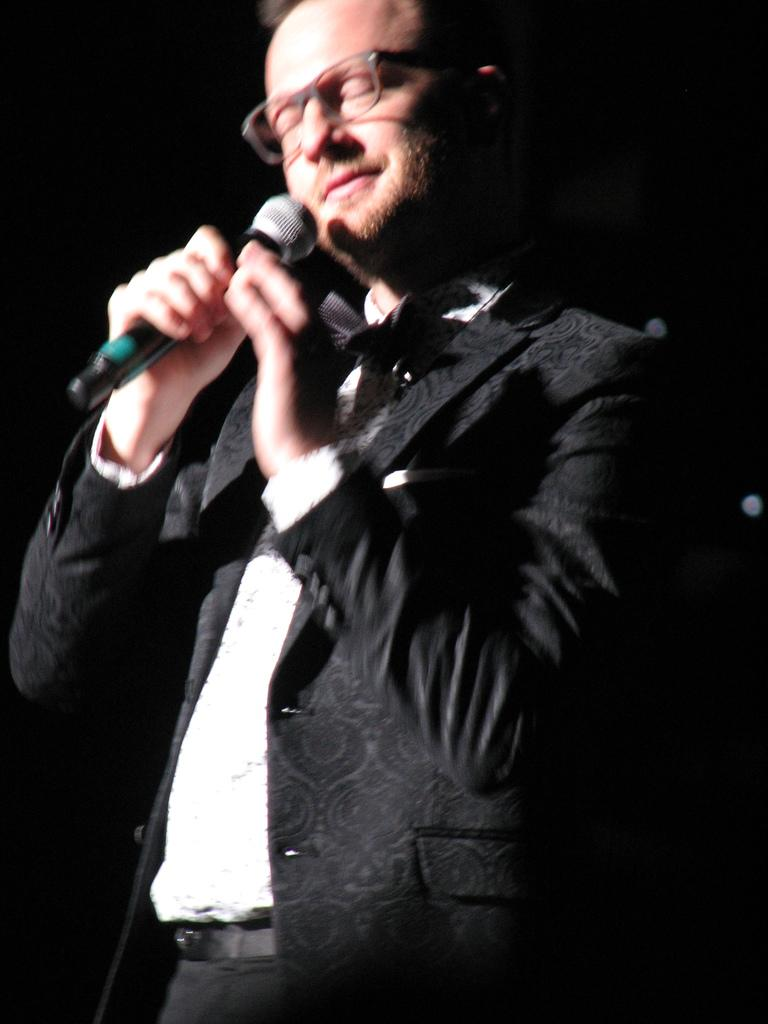What type of clothing is visible in the image? There is a black color coat in the image. What is the person holding in the image? The person is holding a mic in the image. What accessory is the person wearing in the image? The person is wearing spectacles in the image. What type of accessory is visible around the person's waist? The person is wearing a belt in the image. How does the person fold the cap in the image? There is no cap present in the image, so the person cannot fold a cap. 